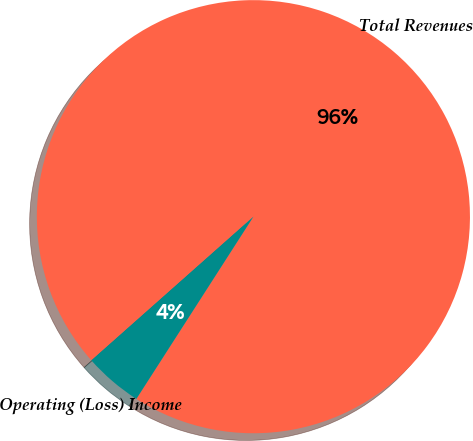<chart> <loc_0><loc_0><loc_500><loc_500><pie_chart><fcel>Total Revenues<fcel>Operating (Loss) Income<nl><fcel>95.63%<fcel>4.37%<nl></chart> 